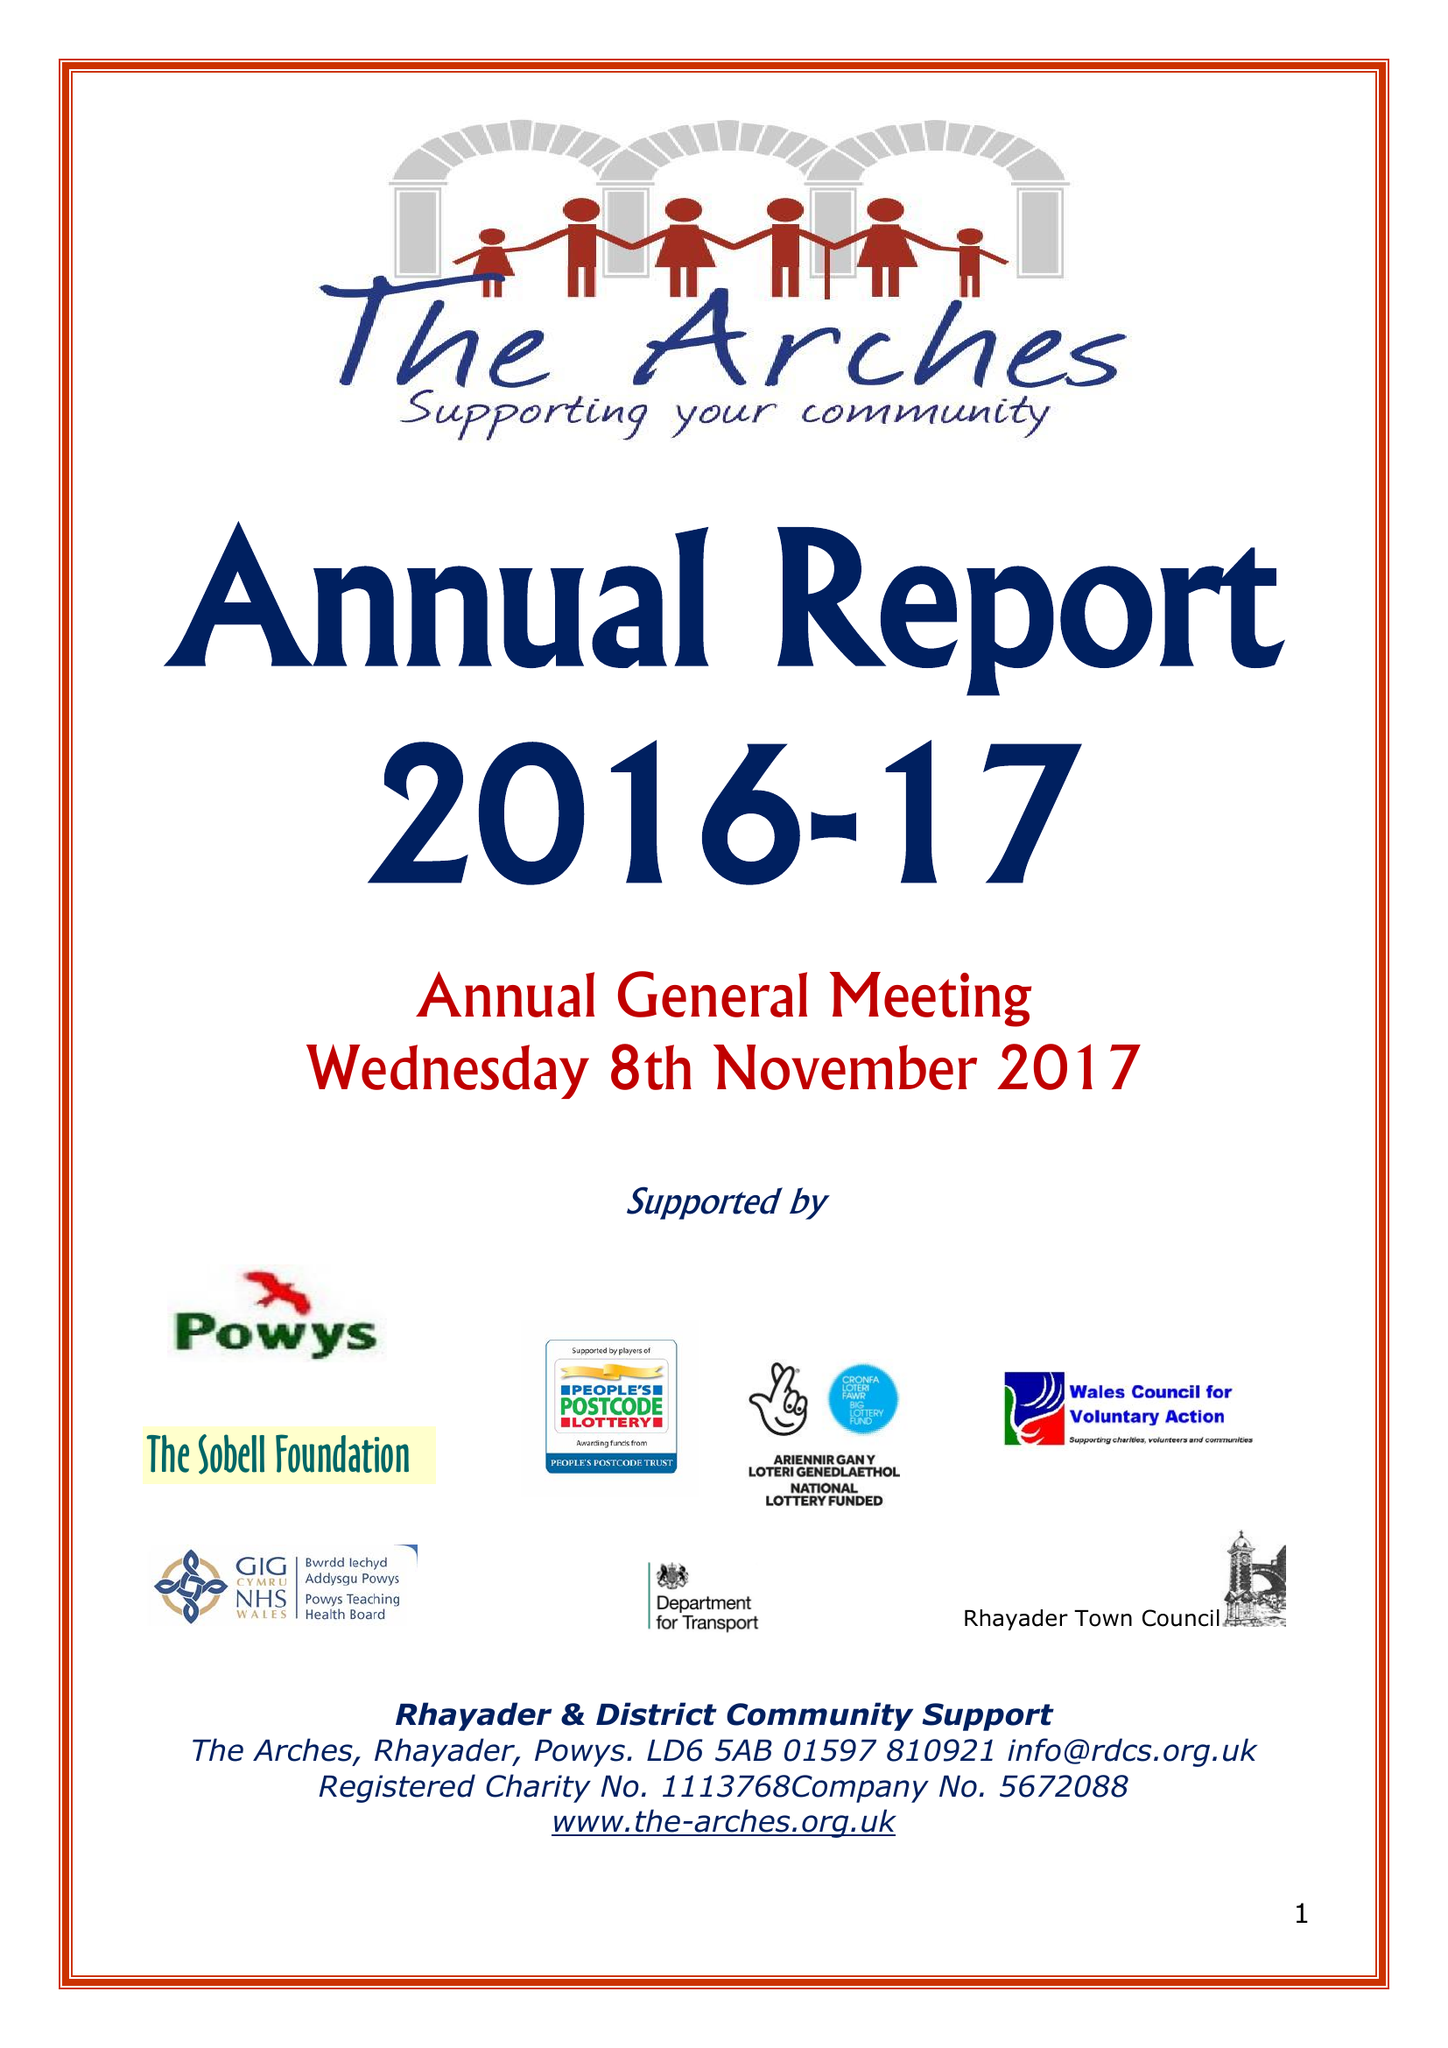What is the value for the income_annually_in_british_pounds?
Answer the question using a single word or phrase. 227751.00 